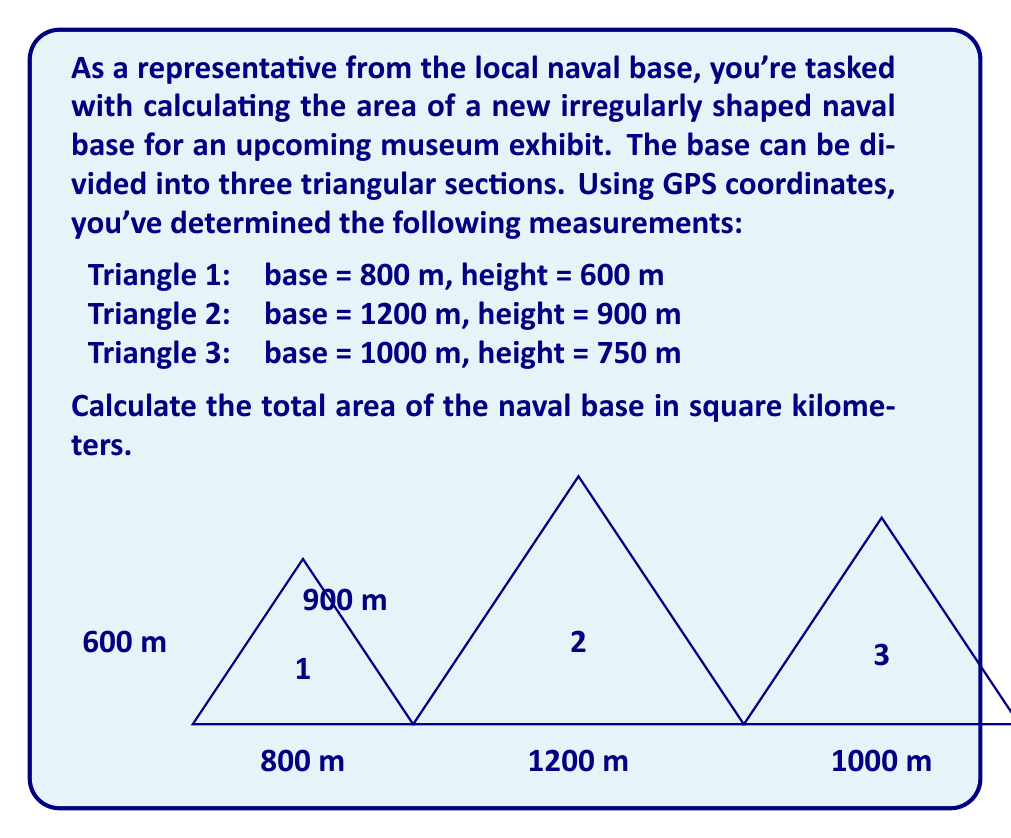Teach me how to tackle this problem. To solve this problem, we need to:
1. Calculate the area of each triangle
2. Sum the areas
3. Convert the total area from square meters to square kilometers

Let's go through each step:

1. Calculating the area of each triangle:
   The formula for the area of a triangle is: $A = \frac{1}{2} \times base \times height$

   Triangle 1: $A_1 = \frac{1}{2} \times 800 \times 600 = 240,000$ m²
   Triangle 2: $A_2 = \frac{1}{2} \times 1200 \times 900 = 540,000$ m²
   Triangle 3: $A_3 = \frac{1}{2} \times 1000 \times 750 = 375,000$ m²

2. Summing the areas:
   $A_{total} = A_1 + A_2 + A_3$
   $A_{total} = 240,000 + 540,000 + 375,000 = 1,155,000$ m²

3. Converting to square kilometers:
   1 km² = 1,000,000 m²
   $A_{km²} = \frac{1,155,000}{1,000,000} = 1.155$ km²

Therefore, the total area of the naval base is 1.155 square kilometers.
Answer: $1.155$ km² 